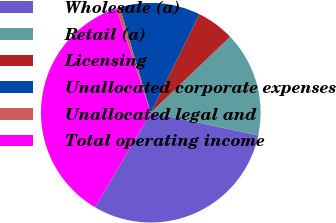Convert chart. <chart><loc_0><loc_0><loc_500><loc_500><pie_chart><fcel>Wholesale (a)<fcel>Retail (a)<fcel>Licensing<fcel>Unallocated corporate expenses<fcel>Unallocated legal and<fcel>Total operating income<nl><fcel>30.18%<fcel>15.45%<fcel>5.54%<fcel>11.86%<fcel>0.52%<fcel>36.46%<nl></chart> 